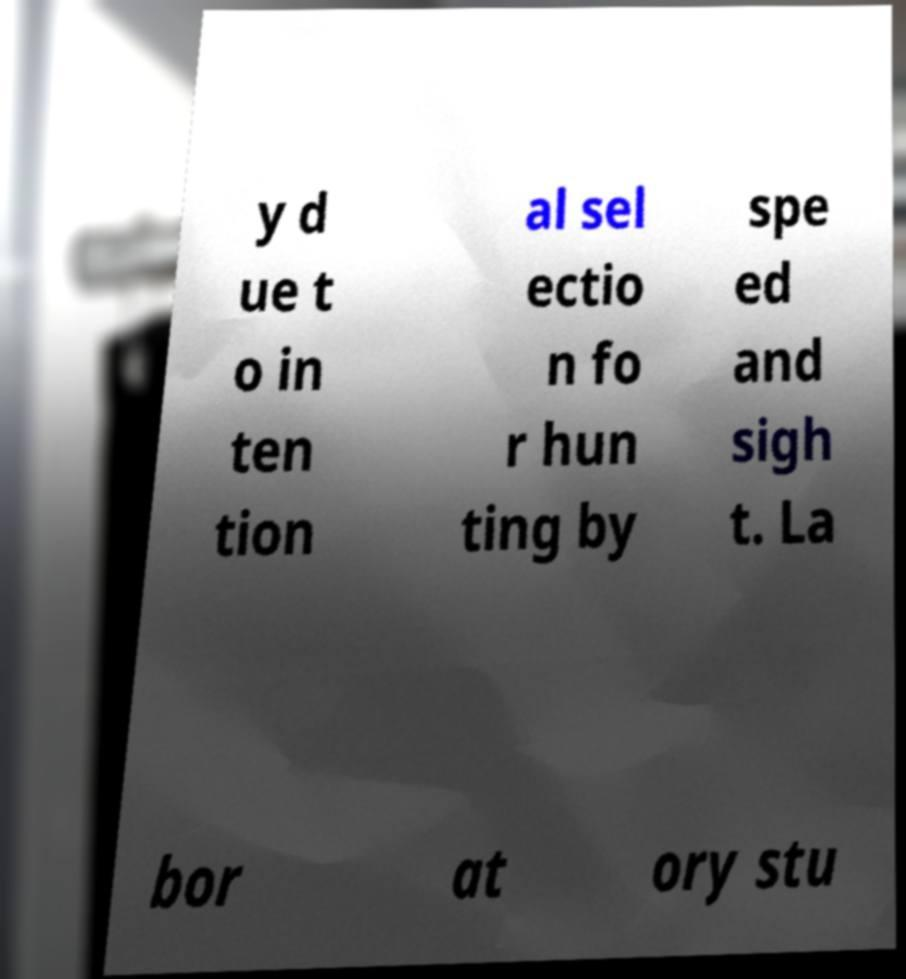Please read and relay the text visible in this image. What does it say? y d ue t o in ten tion al sel ectio n fo r hun ting by spe ed and sigh t. La bor at ory stu 